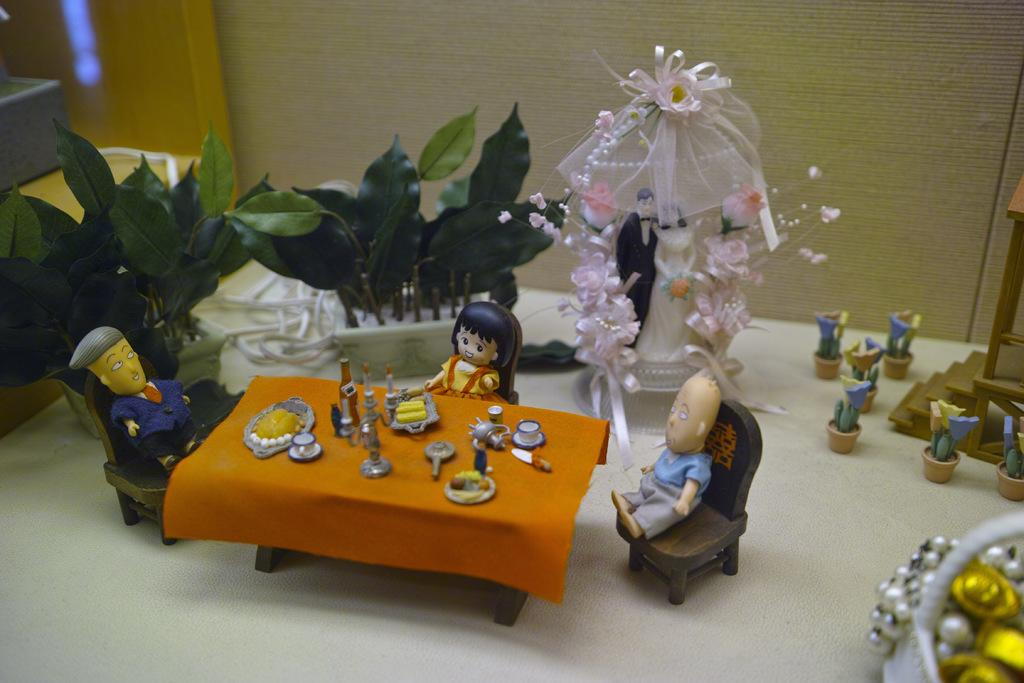What objects can be seen in the image? There are toys in the image. What is located at the top of the image? There is a wall at the top of the image. What type of coal is being used to fuel the toys in the image? There is no coal present in the image, and the toys do not require fuel to function. 